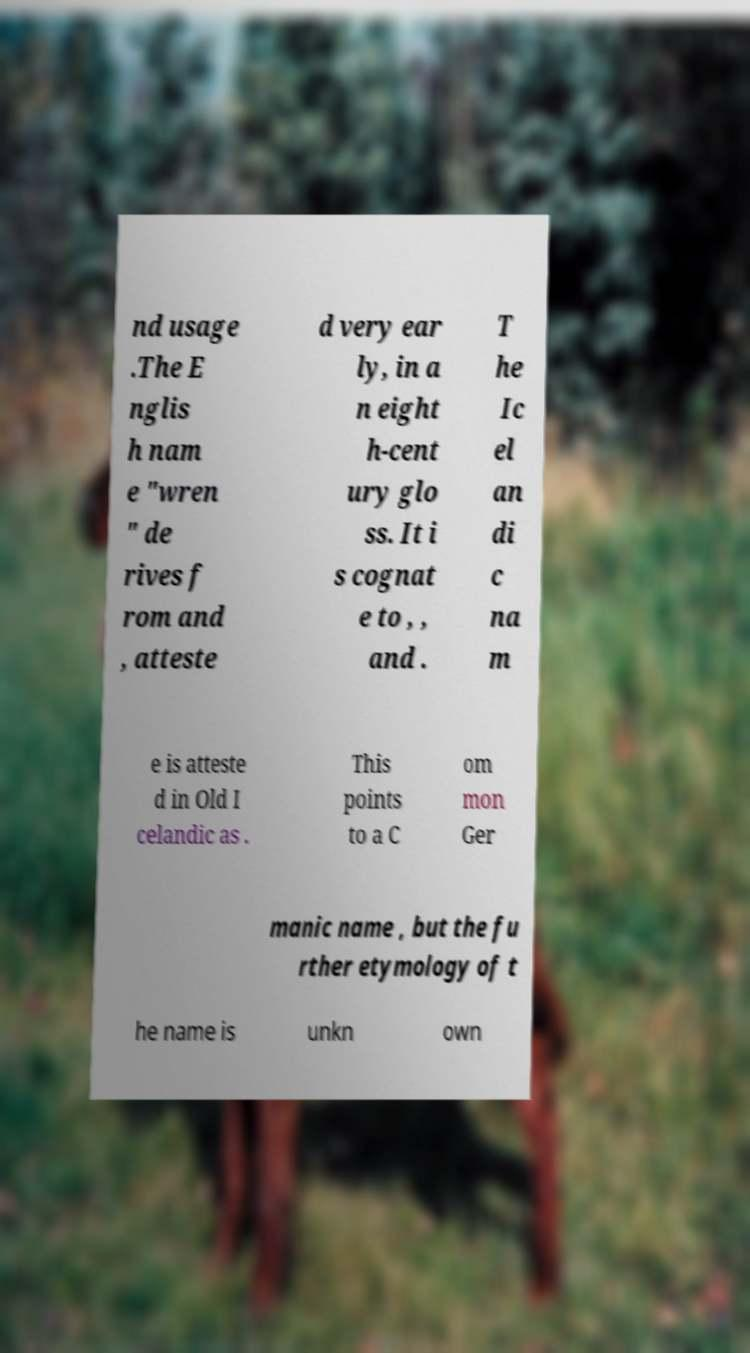Please identify and transcribe the text found in this image. nd usage .The E nglis h nam e "wren " de rives f rom and , atteste d very ear ly, in a n eight h-cent ury glo ss. It i s cognat e to , , and . T he Ic el an di c na m e is atteste d in Old I celandic as . This points to a C om mon Ger manic name , but the fu rther etymology of t he name is unkn own 